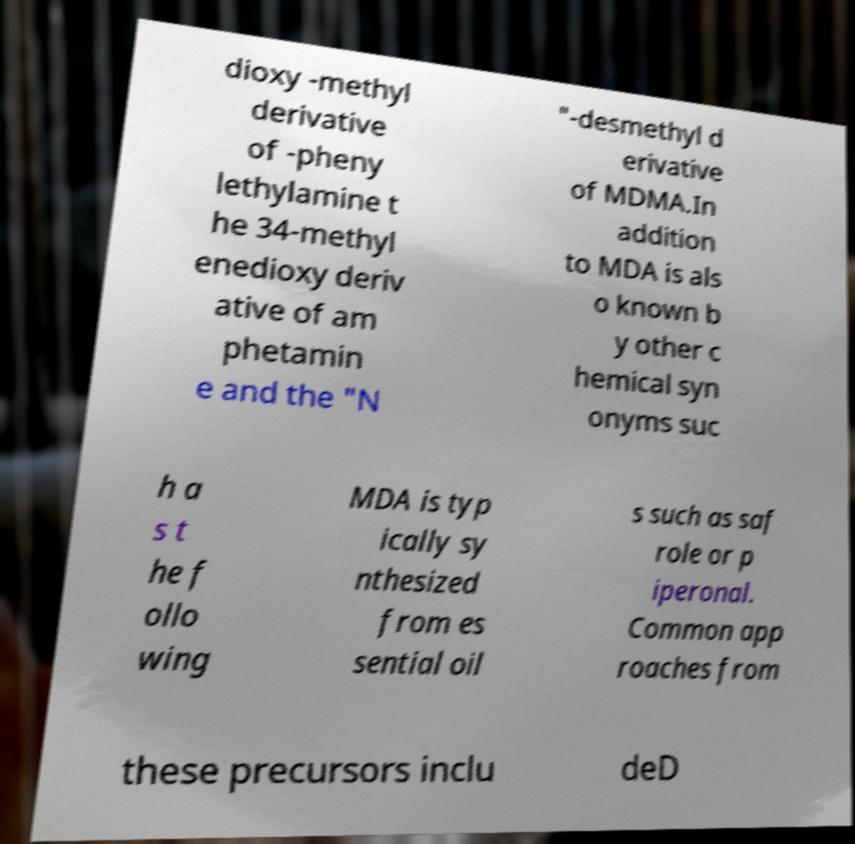What messages or text are displayed in this image? I need them in a readable, typed format. dioxy -methyl derivative of -pheny lethylamine t he 34-methyl enedioxy deriv ative of am phetamin e and the "N "-desmethyl d erivative of MDMA.In addition to MDA is als o known b y other c hemical syn onyms suc h a s t he f ollo wing MDA is typ ically sy nthesized from es sential oil s such as saf role or p iperonal. Common app roaches from these precursors inclu deD 